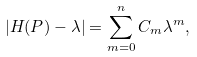<formula> <loc_0><loc_0><loc_500><loc_500>| H ( P ) - \lambda | = \sum _ { m = 0 } ^ { n } C _ { m } \lambda ^ { m } ,</formula> 